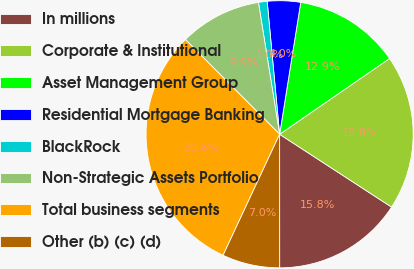Convert chart to OTSL. <chart><loc_0><loc_0><loc_500><loc_500><pie_chart><fcel>In millions<fcel>Corporate & Institutional<fcel>Asset Management Group<fcel>Residential Mortgage Banking<fcel>BlackRock<fcel>Non-Strategic Assets Portfolio<fcel>Total business segments<fcel>Other (b) (c) (d)<nl><fcel>15.82%<fcel>18.78%<fcel>12.87%<fcel>4.01%<fcel>1.05%<fcel>9.92%<fcel>30.59%<fcel>6.96%<nl></chart> 